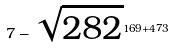Convert formula to latex. <formula><loc_0><loc_0><loc_500><loc_500>7 - \sqrt { 2 8 2 } ^ { 1 6 9 + 4 7 3 }</formula> 